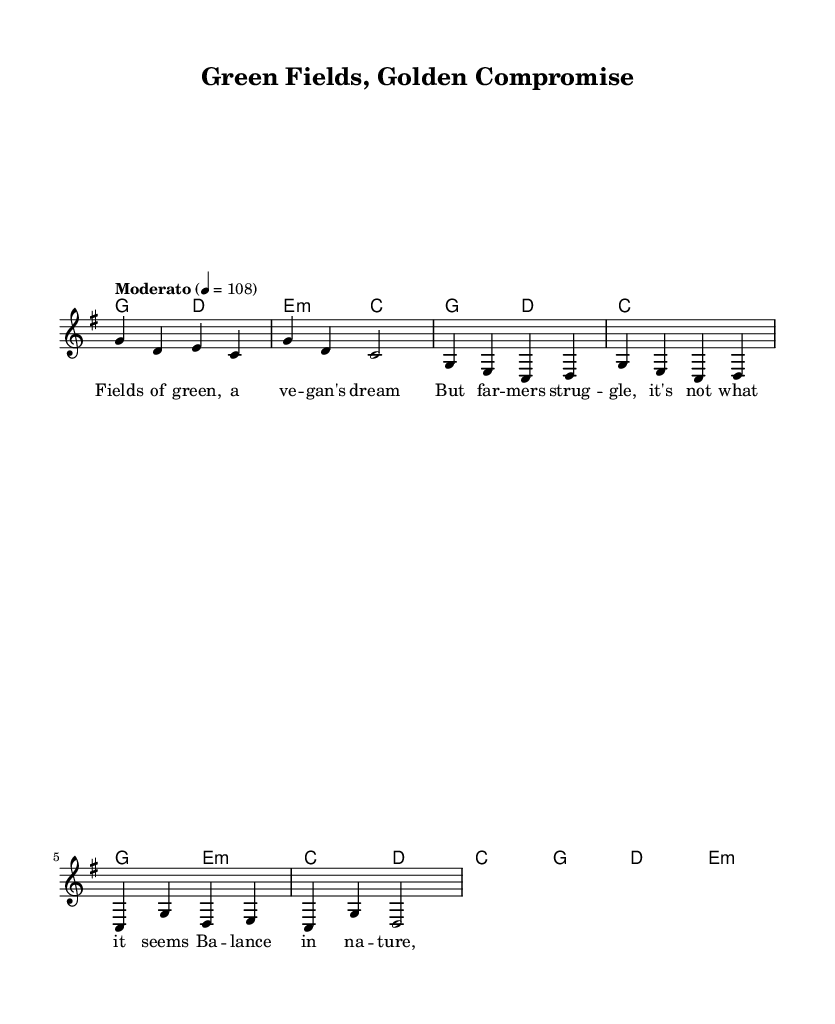What is the key signature of this music? The key signature is G major, which has one sharp (F#) indicated at the beginning of the staff.
Answer: G major What is the time signature of the music? The time signature shown at the beginning is 4/4, indicating that there are four beats in each measure and the quarter note gets one beat.
Answer: 4/4 What is the tempo marking for this piece? The tempo marking is indicated as "Moderato" with a speed of 108 beats per minute, suggesting a moderately paced performance.
Answer: Moderato, 108 How many measures are in the intro? The intro consists of four measures, as shown at the beginning of the melody, where four distinct groupings of notes are visually identifiable.
Answer: 4 What does the chorus lyric begin with? The chorus lyrics start with the phrase "Ba -- lance in na -- ture", clearly identifiable within the lyrics section of the score.
Answer: Ba -- lance in na -- ture Which chord accompanies the first measure of the verse? The chord accompanying the first measure of the verse is G major, as indicated in the harmonies section aligned with the melody notes.
Answer: G What is the last note of the melody in the first verse? The last note of the melody in the first verse is D, as seen in the final note of the melody line for verse one.
Answer: D 